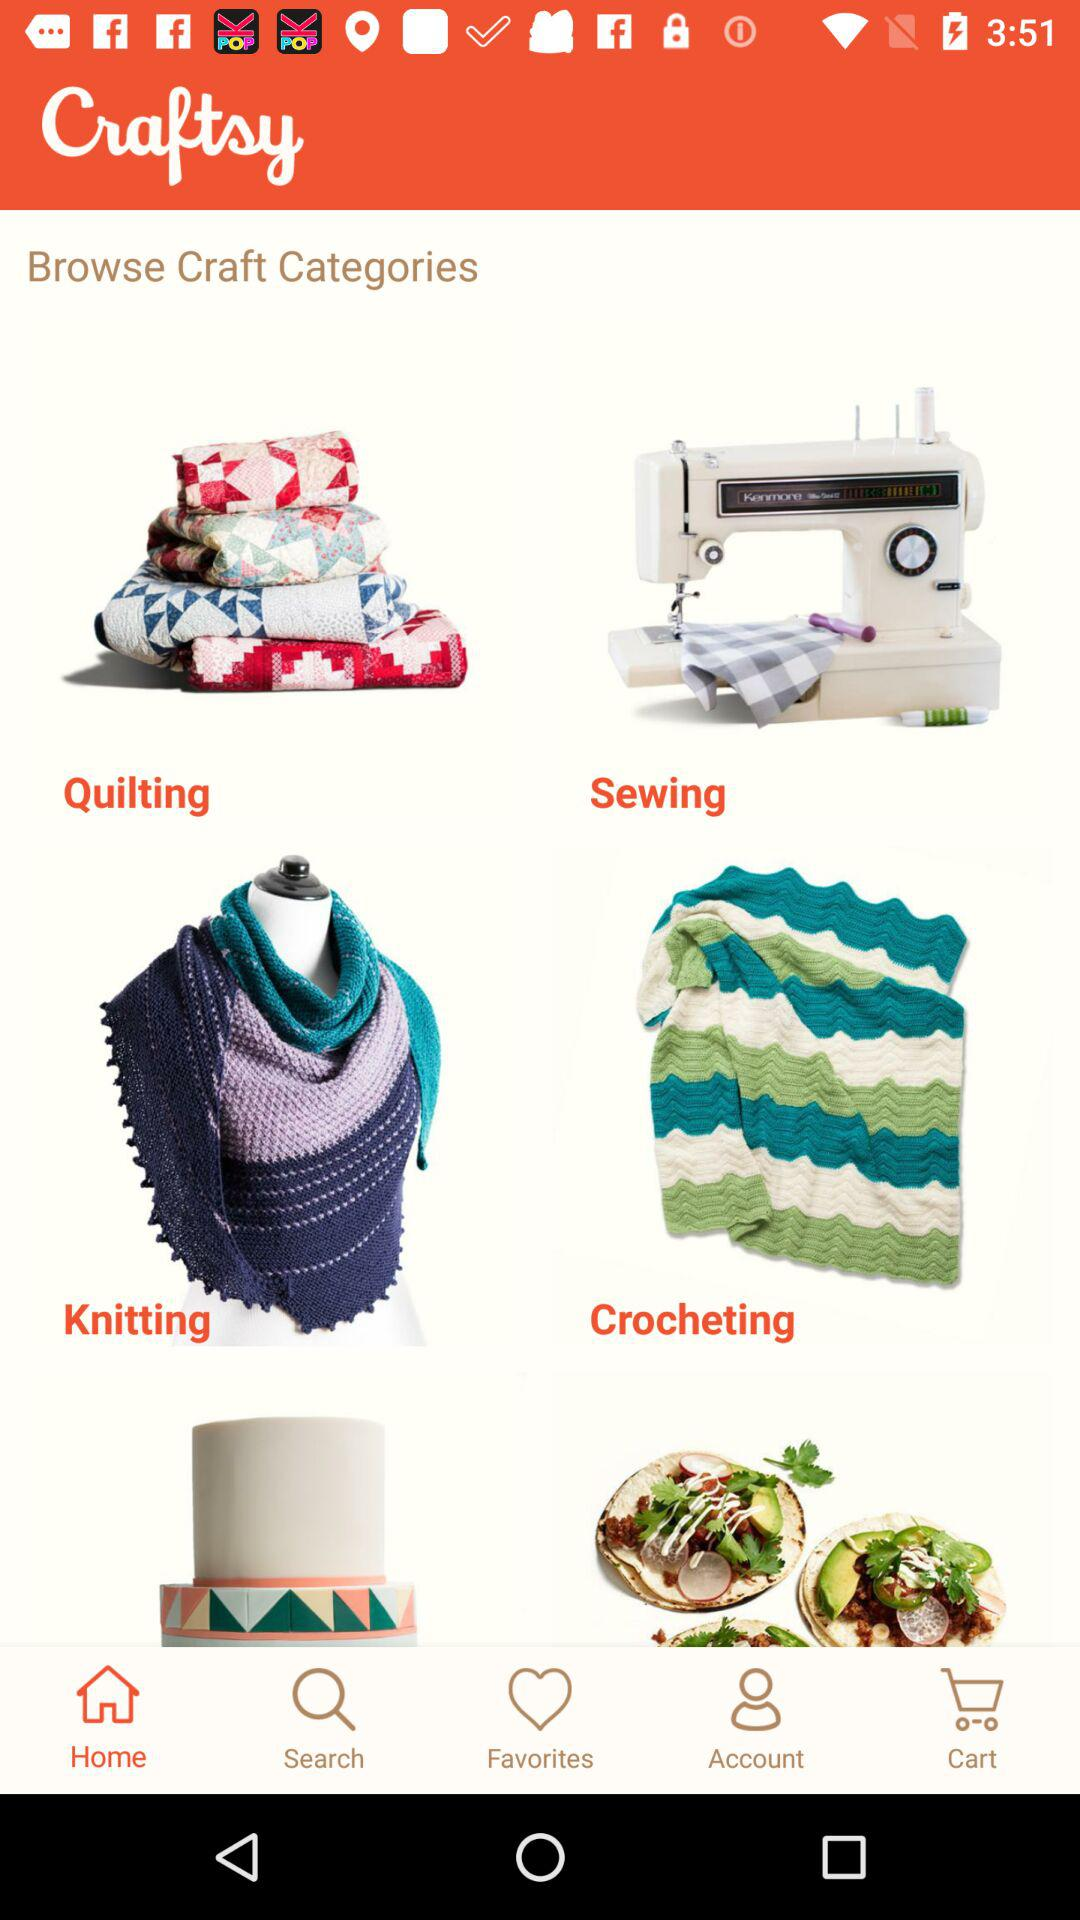What is the name of the application? The name of the application is "Craftsy". 